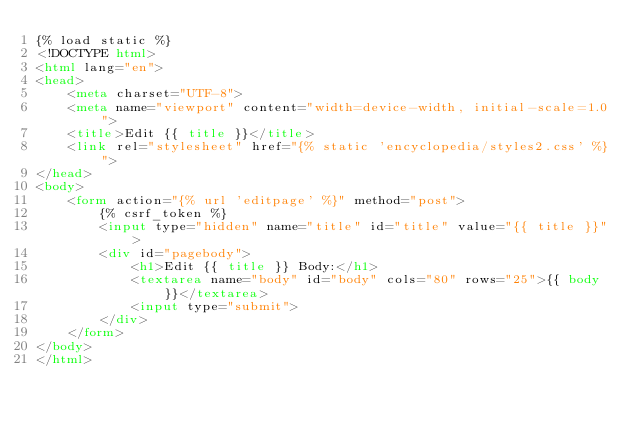Convert code to text. <code><loc_0><loc_0><loc_500><loc_500><_HTML_>{% load static %}
<!DOCTYPE html>
<html lang="en">
<head>
    <meta charset="UTF-8">
    <meta name="viewport" content="width=device-width, initial-scale=1.0">
    <title>Edit {{ title }}</title>
    <link rel="stylesheet" href="{% static 'encyclopedia/styles2.css' %}">
</head>
<body>
    <form action="{% url 'editpage' %}" method="post">
        {% csrf_token %}
        <input type="hidden" name="title" id="title" value="{{ title }}">
        <div id="pagebody">
            <h1>Edit {{ title }} Body:</h1>
            <textarea name="body" id="body" cols="80" rows="25">{{ body }}</textarea>
            <input type="submit">
        </div>
    </form>
</body>
</html></code> 